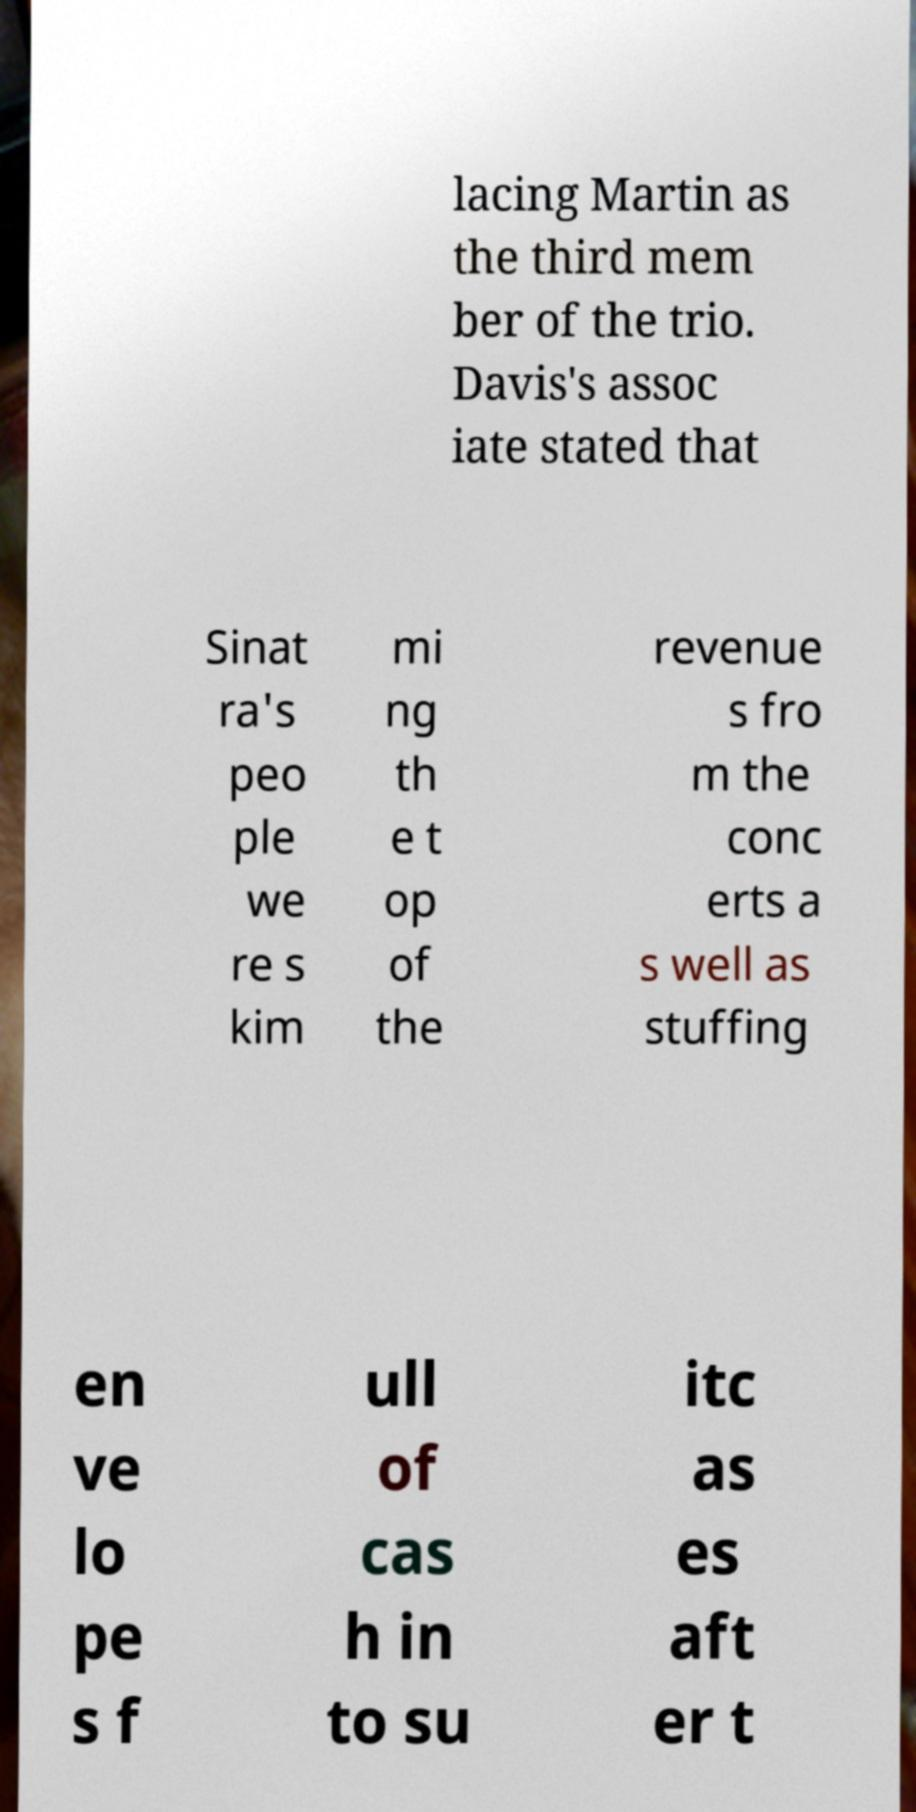For documentation purposes, I need the text within this image transcribed. Could you provide that? lacing Martin as the third mem ber of the trio. Davis's assoc iate stated that Sinat ra's peo ple we re s kim mi ng th e t op of the revenue s fro m the conc erts a s well as stuffing en ve lo pe s f ull of cas h in to su itc as es aft er t 